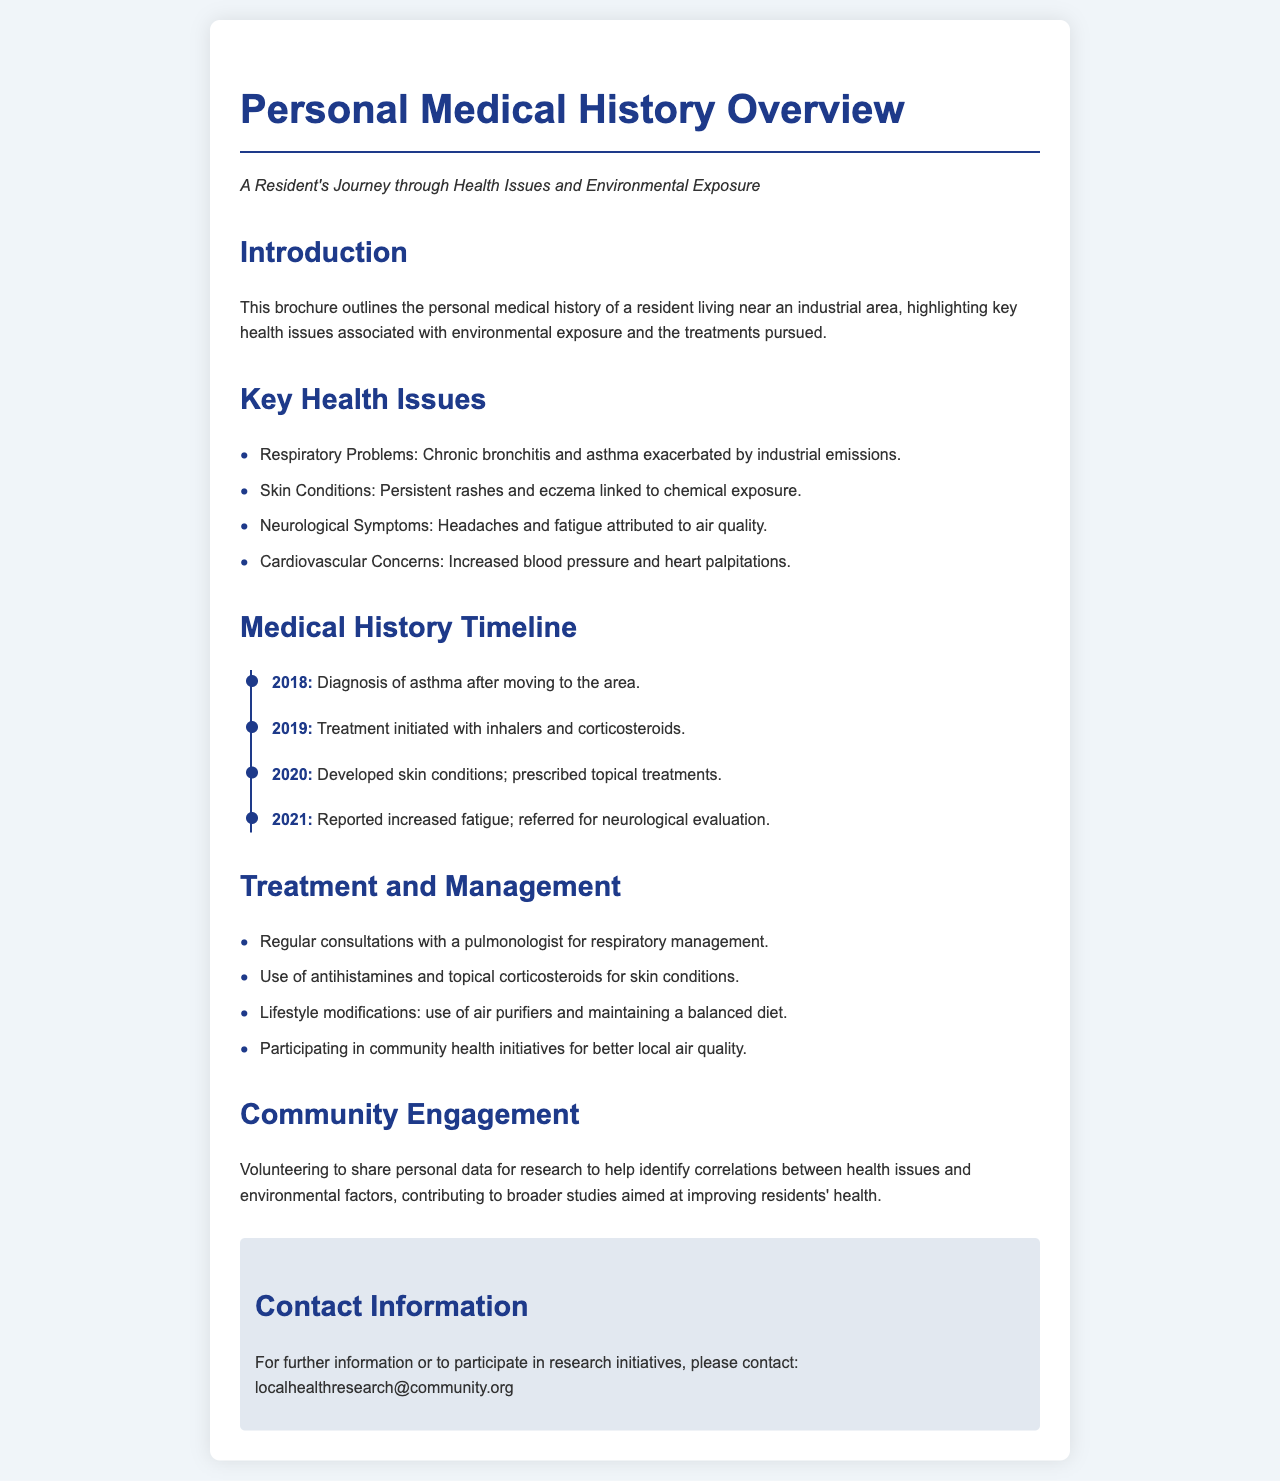What are the chronic conditions mentioned? The document lists specific health issues associated with the resident's medical history, including respiratory and skin conditions.
Answer: Respiratory Problems, Skin Conditions What year was asthma diagnosed? The timeline in the document specifies when the resident was diagnosed with asthma.
Answer: 2018 What treatment was initiated in 2019? The document outlines the treatments pursued over the years, detailing what was started in 2019.
Answer: Inhalers and corticosteroids Which condition led to a referral for evaluation in 2021? The document indicates the reason for further medical evaluation based on reported symptoms.
Answer: Fatigue What lifestyle modifications are mentioned for management? The document lists specific actions taken by the resident to manage their health.
Answer: Use of air purifiers and maintaining a balanced diet How many key health issues are listed? The bullet points in the document enumerate the health issues faced by the resident.
Answer: Four What is the purpose of community engagement highlighted in the brochure? The document describes the aim behind sharing personal data with the community.
Answer: Identify correlations between health issues and environmental factors What is the contact email for research initiatives? The brochure provides an email address for those interested in learning more or participating.
Answer: localhealthresearch@community.org 